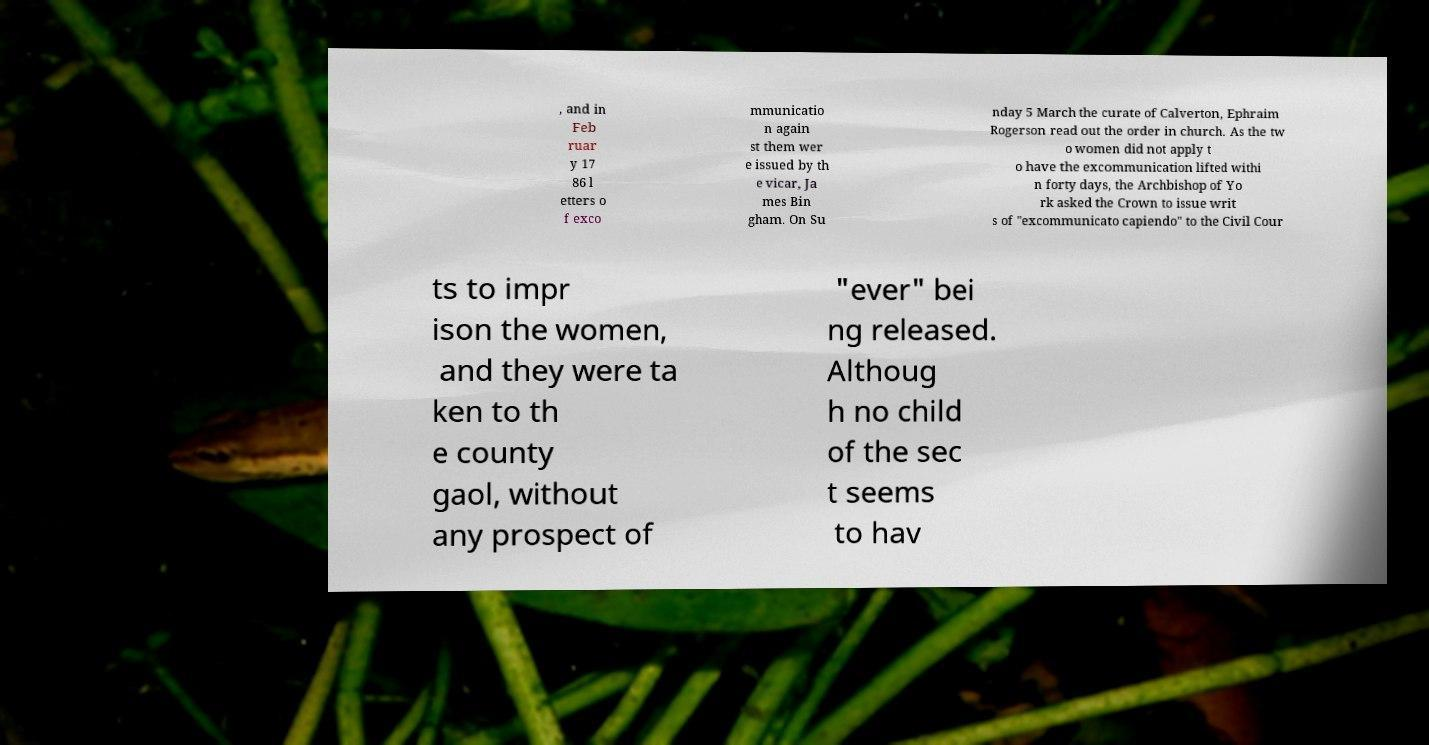For documentation purposes, I need the text within this image transcribed. Could you provide that? , and in Feb ruar y 17 86 l etters o f exco mmunicatio n again st them wer e issued by th e vicar, Ja mes Bin gham. On Su nday 5 March the curate of Calverton, Ephraim Rogerson read out the order in church. As the tw o women did not apply t o have the excommunication lifted withi n forty days, the Archbishop of Yo rk asked the Crown to issue writ s of "excommunicato capiendo" to the Civil Cour ts to impr ison the women, and they were ta ken to th e county gaol, without any prospect of "ever" bei ng released. Althoug h no child of the sec t seems to hav 